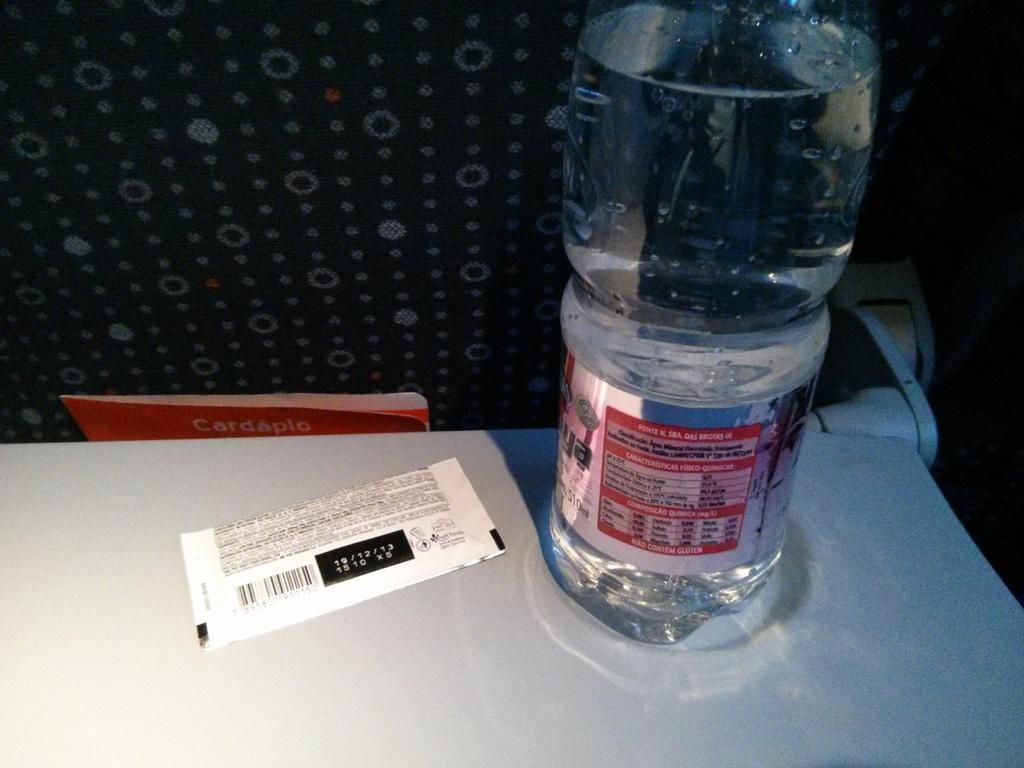Provide a one-sentence caption for the provided image. The date shown on the ticket on the table is 19/12/13. 